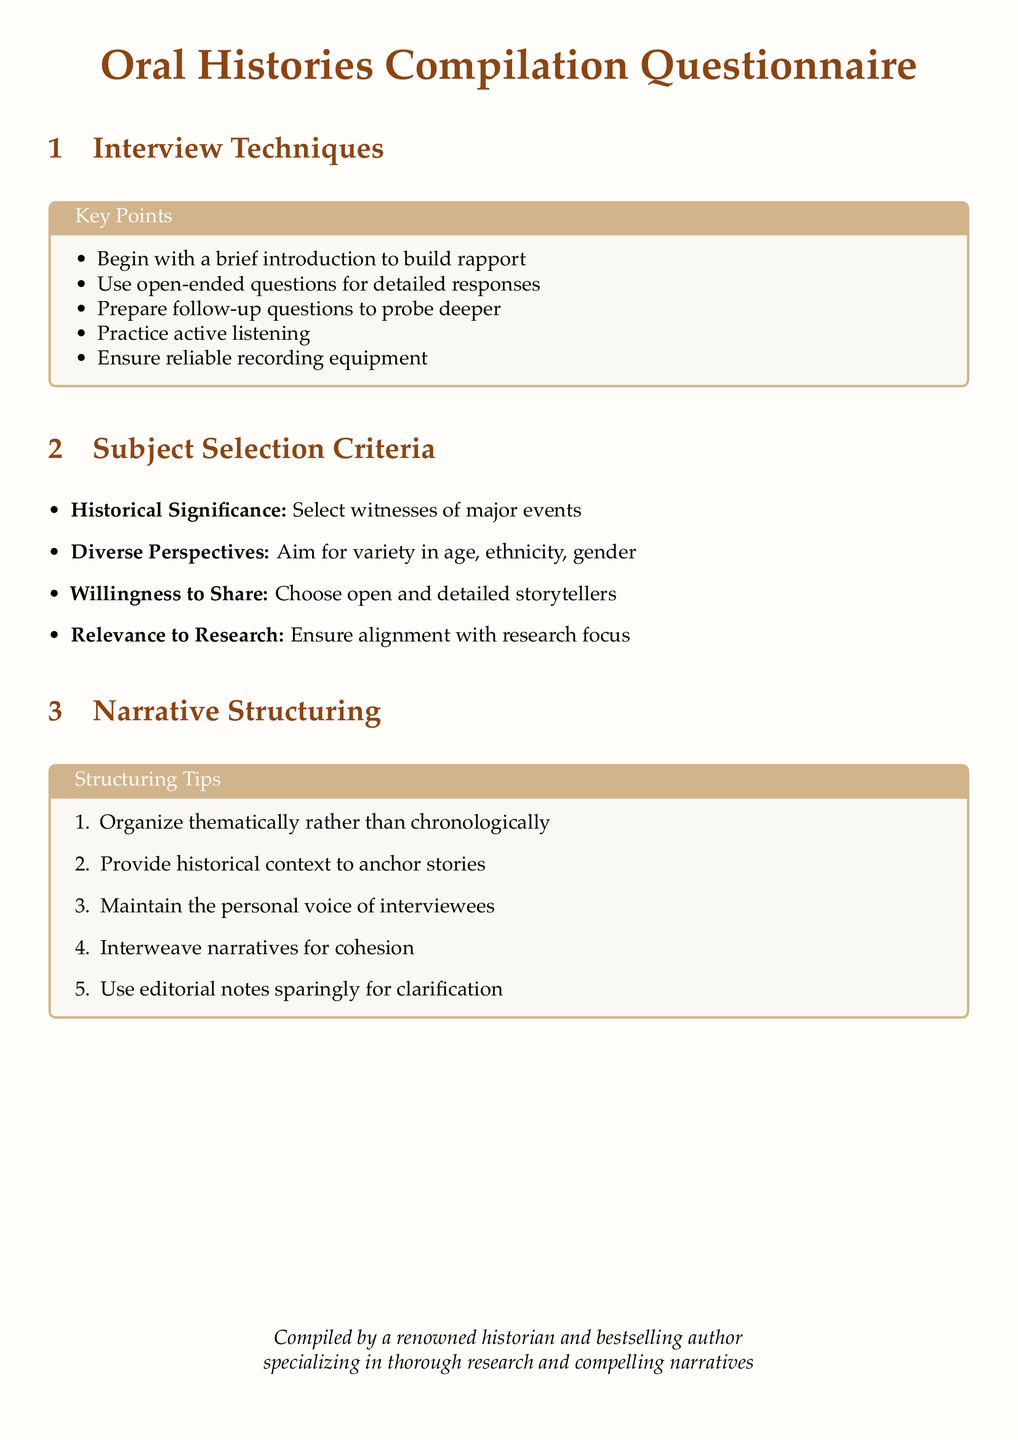what is the title of the document? The title of the document is prominently displayed at the top and centers around the theme of oral histories.
Answer: Oral Histories Compilation Questionnaire how many key points are listed under Interview Techniques? The section includes a list of specific interview techniques for conducting oral histories.
Answer: 5 what is the first subject selection criterion mentioned? The subject selection criteria are listed in a defining order, with the first criterion noted clearly.
Answer: Historical Significance how many structuring tips are provided for narrative structuring? The tips are organized in a numbered list for clarity and ease of reference.
Answer: 5 which narrative structuring tip emphasizes the importance of personal voice? This tip highlights the importance of maintaining the authenticity and individuality of the interviewee's expression.
Answer: Maintain the personal voice of interviewees what color is used for the main text font? The document specifies a particular color for the main text, reflecting the overall aesthetic design.
Answer: Palatino what type of document is this? The format and content reveal the purpose and nature of the document focused on compiling oral histories.
Answer: Questionnaire what is the color of the background used in the document? The background color is chosen to create a specific visual environment for reading.
Answer: RGB(255,253,250) 